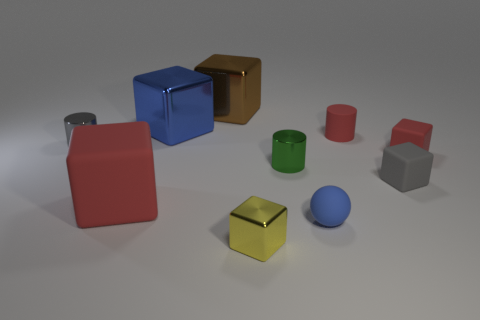Subtract 3 cubes. How many cubes are left? 3 Subtract all brown cubes. How many cubes are left? 5 Subtract all blue cubes. How many cubes are left? 5 Subtract all red cubes. Subtract all purple balls. How many cubes are left? 4 Subtract all blocks. How many objects are left? 4 Subtract 1 gray cylinders. How many objects are left? 9 Subtract all big green shiny things. Subtract all rubber cubes. How many objects are left? 7 Add 7 yellow things. How many yellow things are left? 8 Add 3 large matte objects. How many large matte objects exist? 4 